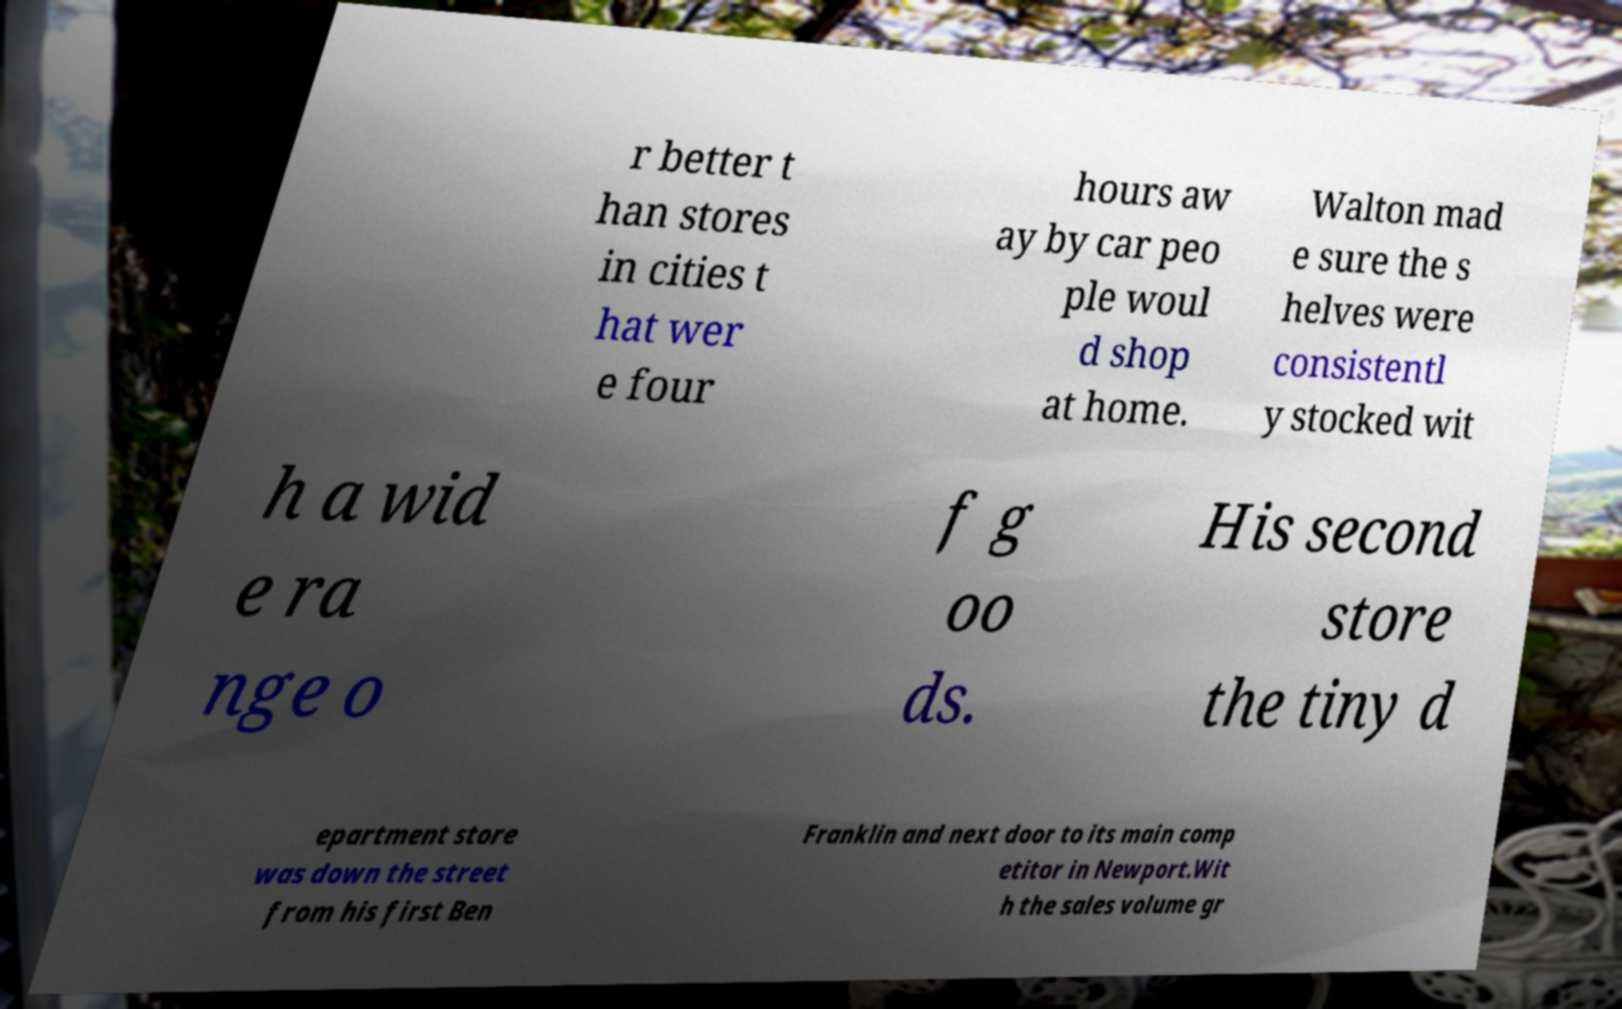Could you assist in decoding the text presented in this image and type it out clearly? r better t han stores in cities t hat wer e four hours aw ay by car peo ple woul d shop at home. Walton mad e sure the s helves were consistentl y stocked wit h a wid e ra nge o f g oo ds. His second store the tiny d epartment store was down the street from his first Ben Franklin and next door to its main comp etitor in Newport.Wit h the sales volume gr 